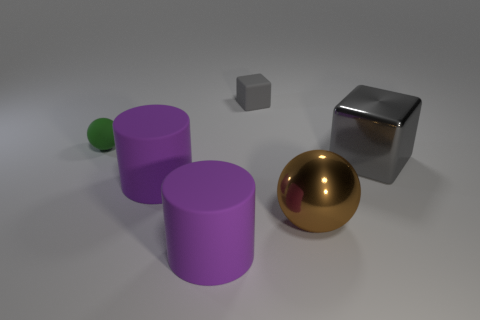If these objects were part of a physics study, what attributes might be examined? In a physics study, one might examine the attributes such as the density and mass of each object, their coefficients of friction due to the different materials, their shapes affecting aerodynamics and stability, reflectivity and thermal properties, and how they might behave under different forces like impact or compression. 